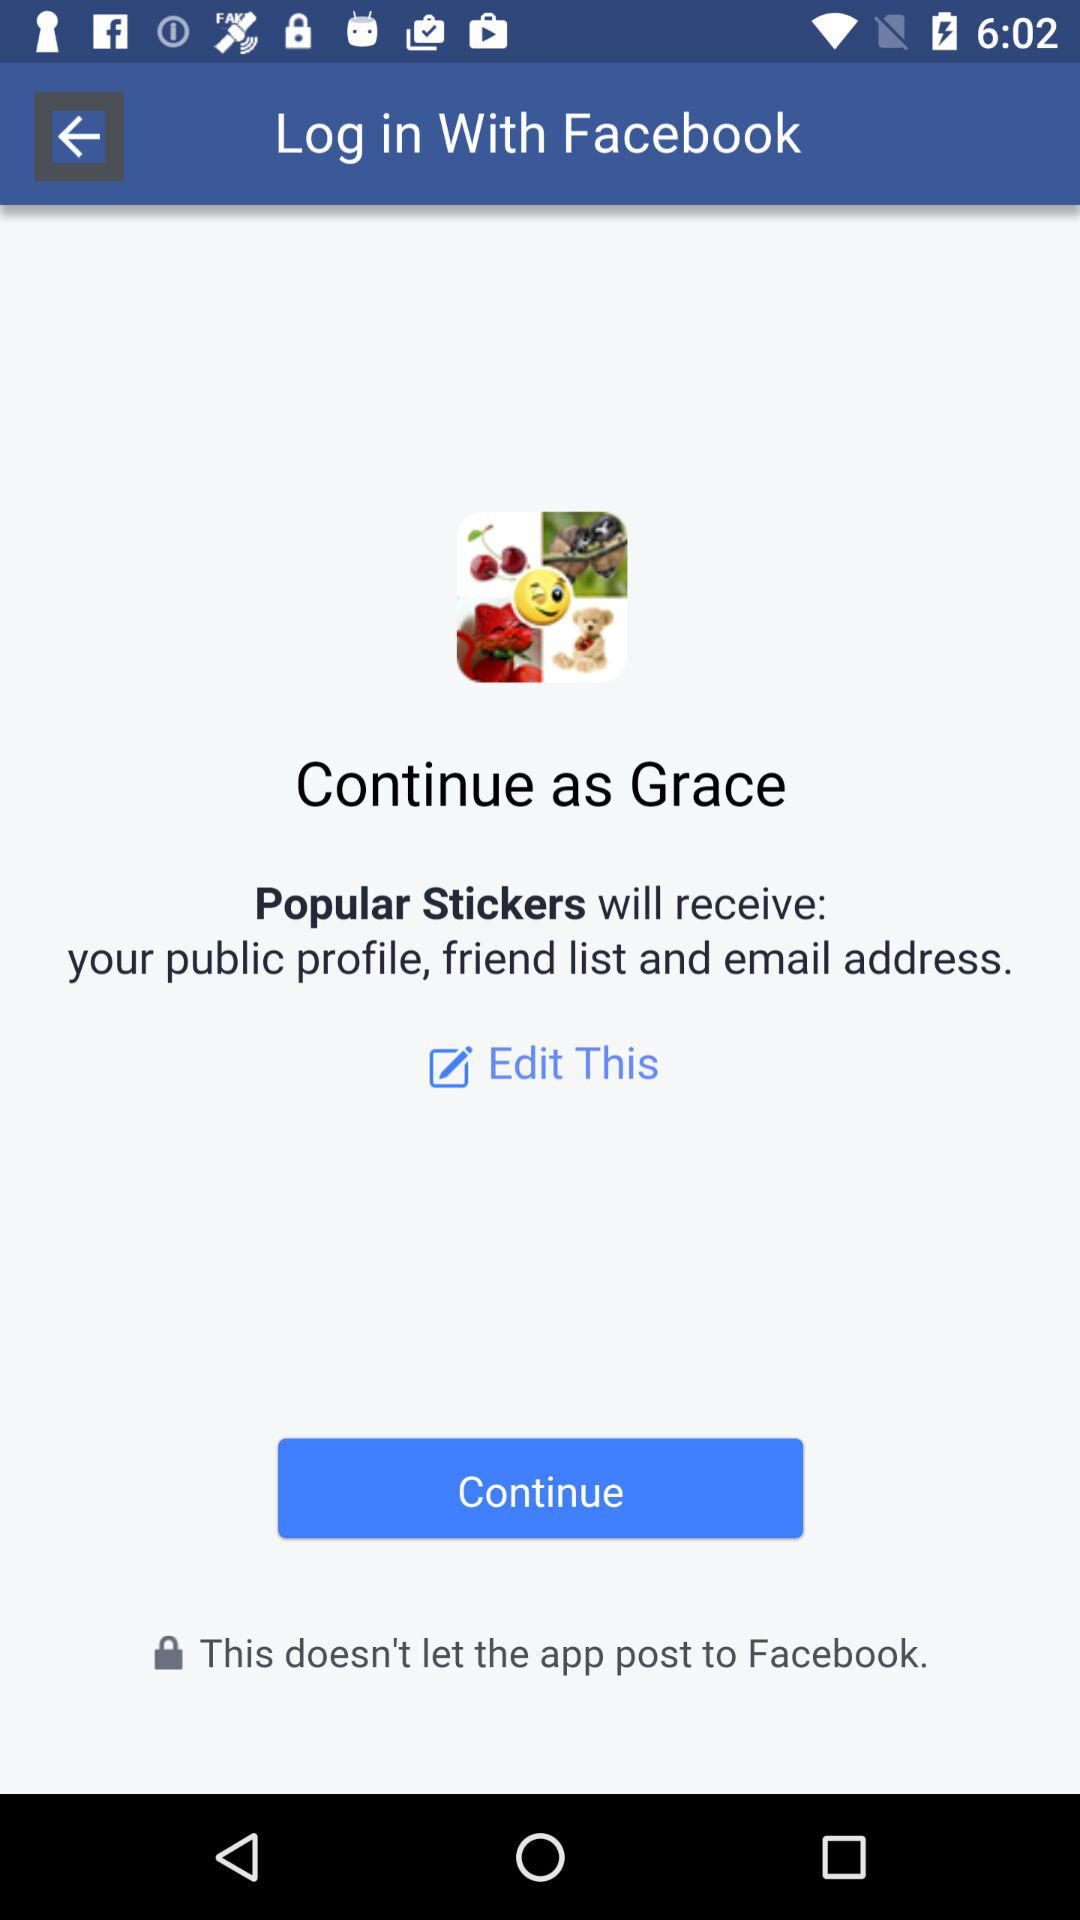What is the login name? The login name is Grace. 